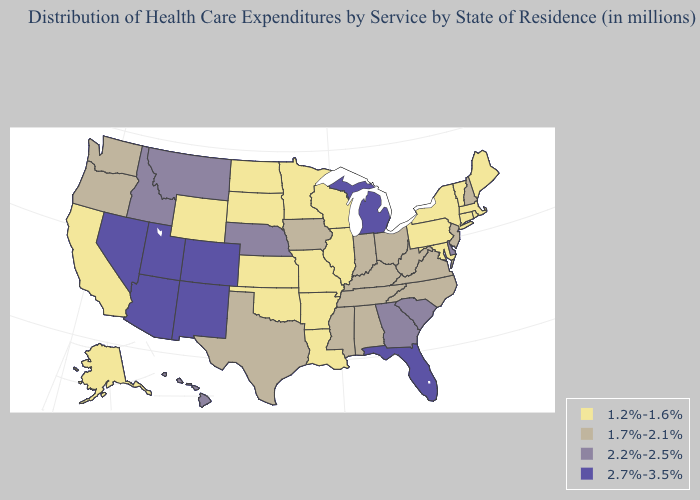Name the states that have a value in the range 1.7%-2.1%?
Short answer required. Alabama, Indiana, Iowa, Kentucky, Mississippi, New Hampshire, New Jersey, North Carolina, Ohio, Oregon, Tennessee, Texas, Virginia, Washington, West Virginia. Does South Carolina have the same value as Maine?
Concise answer only. No. What is the lowest value in states that border Delaware?
Write a very short answer. 1.2%-1.6%. What is the highest value in states that border Utah?
Give a very brief answer. 2.7%-3.5%. Among the states that border North Carolina , does South Carolina have the lowest value?
Be succinct. No. Among the states that border Texas , does Louisiana have the highest value?
Concise answer only. No. Which states have the highest value in the USA?
Keep it brief. Arizona, Colorado, Florida, Michigan, Nevada, New Mexico, Utah. Does the map have missing data?
Short answer required. No. Does Mississippi have the highest value in the USA?
Write a very short answer. No. What is the highest value in the USA?
Quick response, please. 2.7%-3.5%. Does New Hampshire have the lowest value in the Northeast?
Write a very short answer. No. Does Connecticut have the same value as Colorado?
Short answer required. No. Does Montana have the same value as Virginia?
Answer briefly. No. What is the lowest value in states that border Washington?
Be succinct. 1.7%-2.1%. Among the states that border California , does Oregon have the lowest value?
Quick response, please. Yes. 